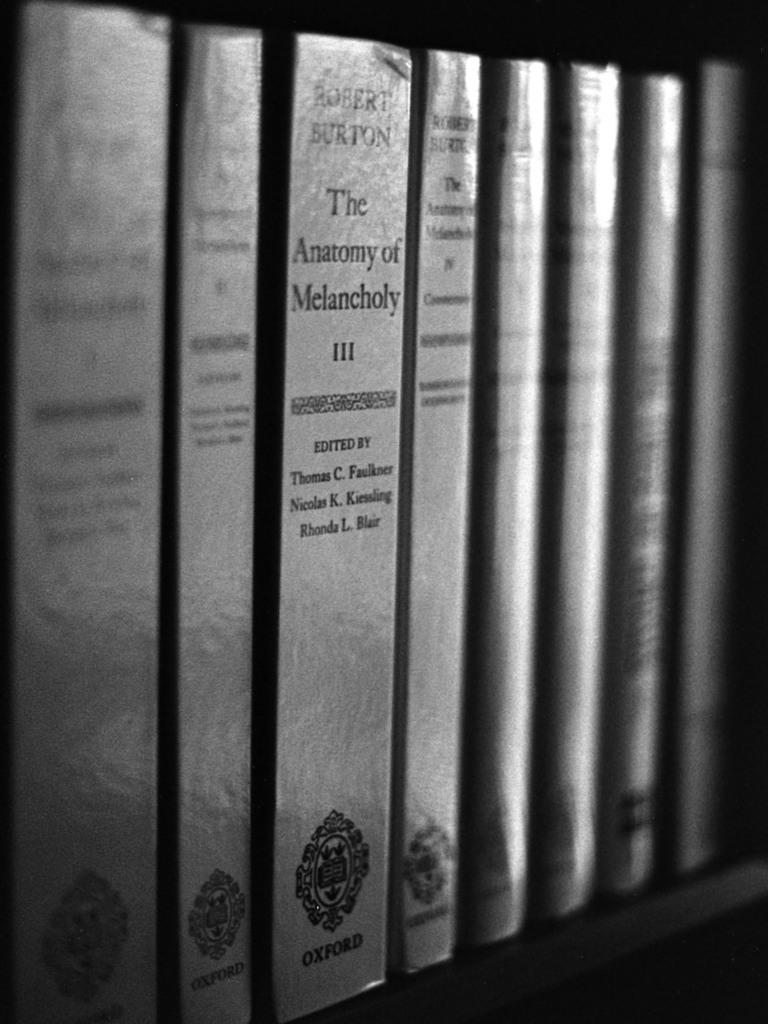<image>
Write a terse but informative summary of the picture. Books line a shelf in black and white, one of the books is titled "The Anatomy of Melancholy." 